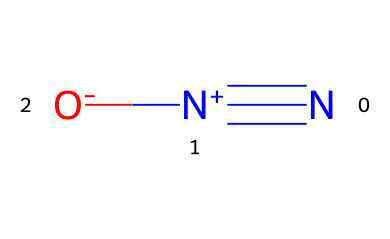What is the molecular formula of nitrous oxide? The SMILES representation indicates that the molecule contains one nitrogen atom connected to another nitrogen atom with a triple bond and a nitrogen connected to an oxygen with a single bond. Therefore, the molecular formula can be deduced as N2O.
Answer: N2O How many total atoms are present in nitrous oxide? From the molecular formula N2O, there are 2 nitrogen atoms and 1 oxygen atom, making a total of 3 atoms (2 + 1 = 3).
Answer: 3 What type of bond connects the two nitrogen atoms in nitrous oxide? The SMILES representation shows a "#" symbol between the two nitrogen atoms, indicating a triple bond between them.
Answer: triple bond Is nitrous oxide a polar molecule? The nitrogen atoms have different electronegativities than the oxygen atom, which causes an uneven distribution of charge, leading to a dipole moment; hence, nitrous oxide is considered a polar molecule.
Answer: polar What is the charge of the nitrogen atom in nitrous oxide connected to the oxygen? The "[N+]" in the SMILES indicates that this nitrogen atom has a positive charge.
Answer: positive What type of chemical is nitrous oxide categorized under? Since nitrous oxide is a gaseous compound used primarily as an anesthetic, it falls under the category of anesthetic gases.
Answer: anesthetic gas Why is nitrous oxide commonly used in medical procedures? Nitrous oxide is often used for its anesthetic and analgesic properties, providing pain relief and sedation during medical procedures, thanks to its ability to induce a calm and pain-free state.
Answer: pain relief 